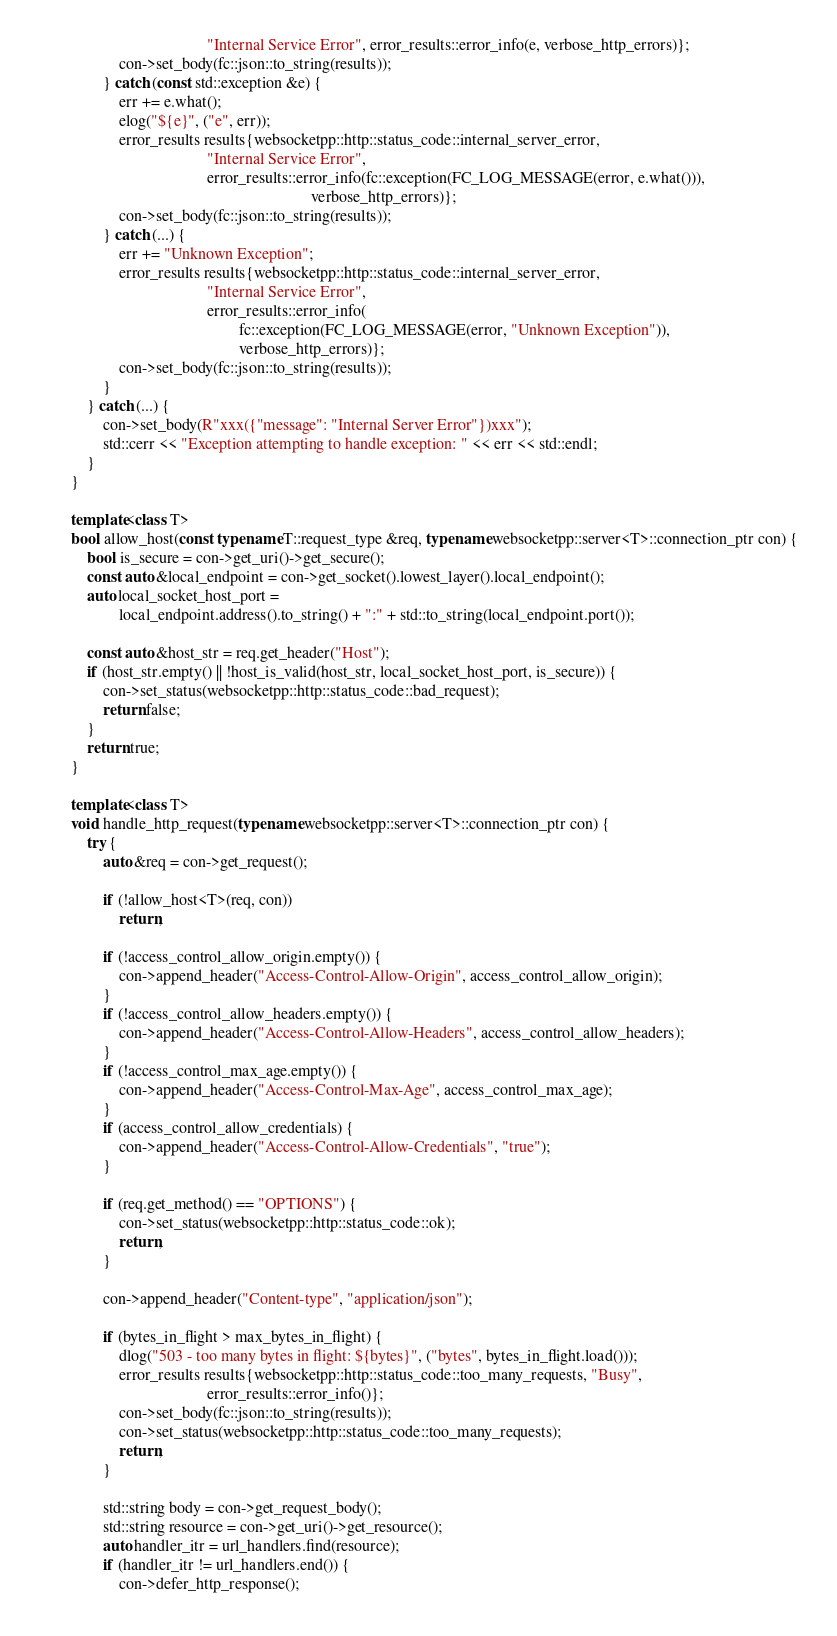<code> <loc_0><loc_0><loc_500><loc_500><_C++_>                                          "Internal Service Error", error_results::error_info(e, verbose_http_errors)};
                    con->set_body(fc::json::to_string(results));
                } catch (const std::exception &e) {
                    err += e.what();
                    elog("${e}", ("e", err));
                    error_results results{websocketpp::http::status_code::internal_server_error,
                                          "Internal Service Error",
                                          error_results::error_info(fc::exception(FC_LOG_MESSAGE(error, e.what())),
                                                                    verbose_http_errors)};
                    con->set_body(fc::json::to_string(results));
                } catch (...) {
                    err += "Unknown Exception";
                    error_results results{websocketpp::http::status_code::internal_server_error,
                                          "Internal Service Error",
                                          error_results::error_info(
                                                  fc::exception(FC_LOG_MESSAGE(error, "Unknown Exception")),
                                                  verbose_http_errors)};
                    con->set_body(fc::json::to_string(results));
                }
            } catch (...) {
                con->set_body(R"xxx({"message": "Internal Server Error"})xxx");
                std::cerr << "Exception attempting to handle exception: " << err << std::endl;
            }
        }

        template<class T>
        bool allow_host(const typename T::request_type &req, typename websocketpp::server<T>::connection_ptr con) {
            bool is_secure = con->get_uri()->get_secure();
            const auto &local_endpoint = con->get_socket().lowest_layer().local_endpoint();
            auto local_socket_host_port =
                    local_endpoint.address().to_string() + ":" + std::to_string(local_endpoint.port());

            const auto &host_str = req.get_header("Host");
            if (host_str.empty() || !host_is_valid(host_str, local_socket_host_port, is_secure)) {
                con->set_status(websocketpp::http::status_code::bad_request);
                return false;
            }
            return true;
        }

        template<class T>
        void handle_http_request(typename websocketpp::server<T>::connection_ptr con) {
            try {
                auto &req = con->get_request();

                if (!allow_host<T>(req, con))
                    return;

                if (!access_control_allow_origin.empty()) {
                    con->append_header("Access-Control-Allow-Origin", access_control_allow_origin);
                }
                if (!access_control_allow_headers.empty()) {
                    con->append_header("Access-Control-Allow-Headers", access_control_allow_headers);
                }
                if (!access_control_max_age.empty()) {
                    con->append_header("Access-Control-Max-Age", access_control_max_age);
                }
                if (access_control_allow_credentials) {
                    con->append_header("Access-Control-Allow-Credentials", "true");
                }

                if (req.get_method() == "OPTIONS") {
                    con->set_status(websocketpp::http::status_code::ok);
                    return;
                }

                con->append_header("Content-type", "application/json");

                if (bytes_in_flight > max_bytes_in_flight) {
                    dlog("503 - too many bytes in flight: ${bytes}", ("bytes", bytes_in_flight.load()));
                    error_results results{websocketpp::http::status_code::too_many_requests, "Busy",
                                          error_results::error_info()};
                    con->set_body(fc::json::to_string(results));
                    con->set_status(websocketpp::http::status_code::too_many_requests);
                    return;
                }

                std::string body = con->get_request_body();
                std::string resource = con->get_uri()->get_resource();
                auto handler_itr = url_handlers.find(resource);
                if (handler_itr != url_handlers.end()) {
                    con->defer_http_response();</code> 